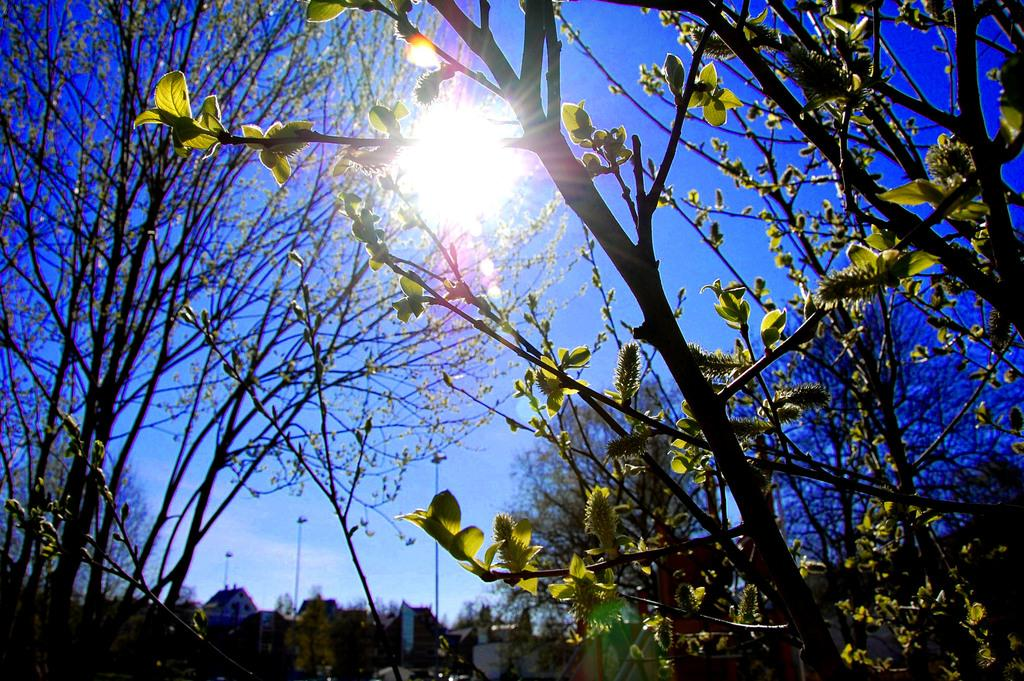What type of vegetation is in the front of the image? There are plants in the front of the image. What type of vegetation is in the background of the image? There are trees in the background of the image. What is visible at the top of the image? The sky is visible at the top of the image. What celestial body is present in the image? The Sun is present in the image. What type of silk is being spun by the beetle in the image? There is no beetle or silk present in the image. How many chickens are visible in the image? There are no chickens present in the image. 